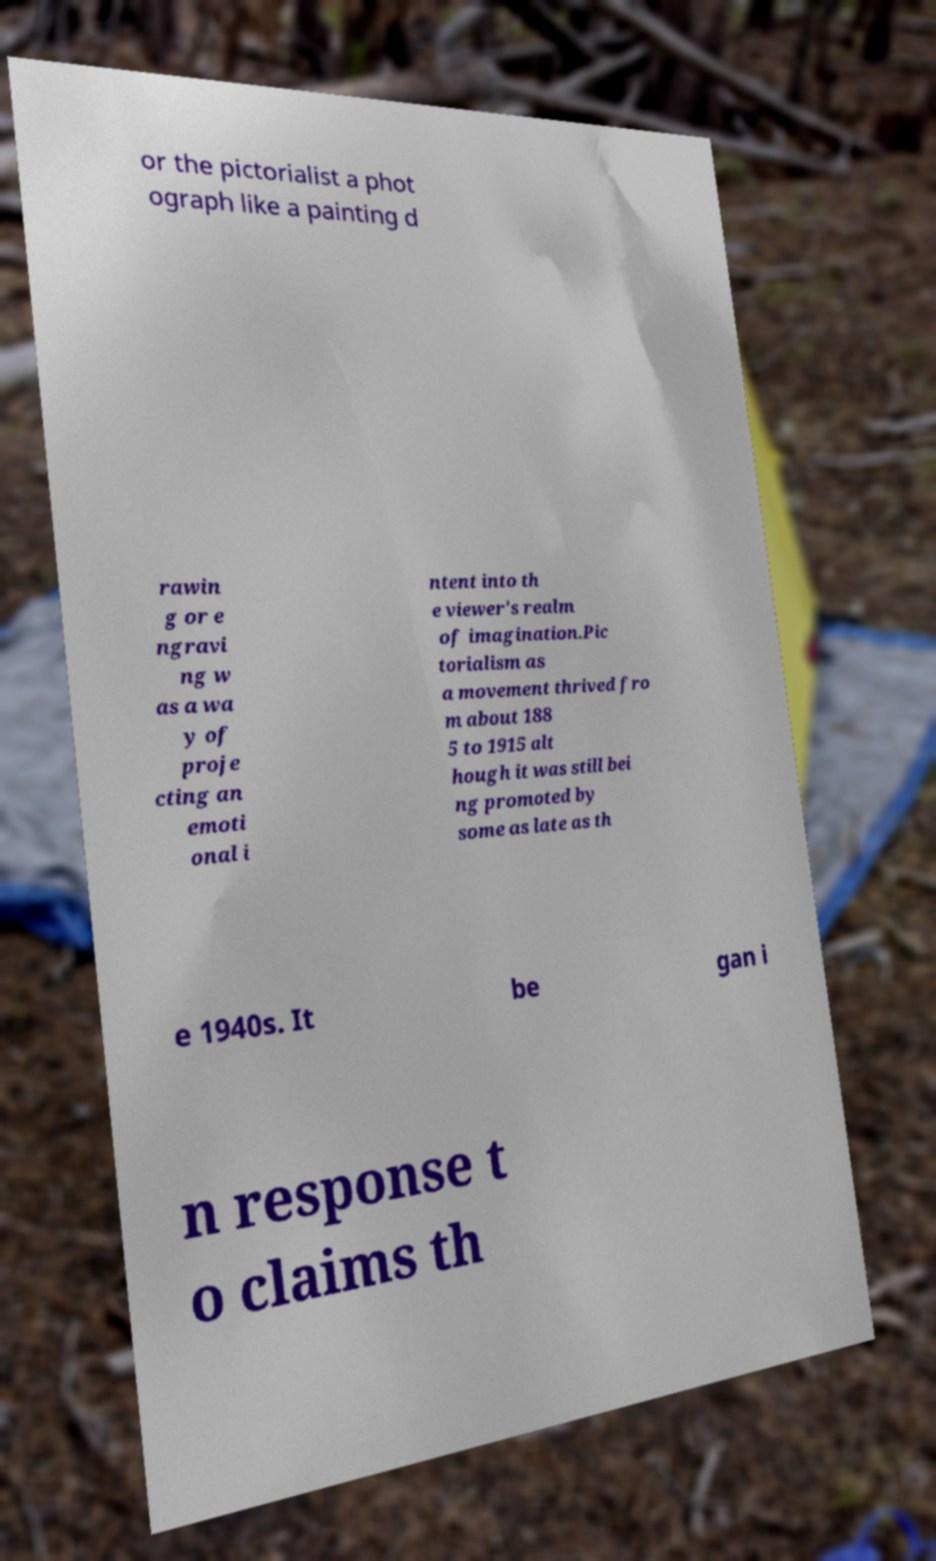Please read and relay the text visible in this image. What does it say? or the pictorialist a phot ograph like a painting d rawin g or e ngravi ng w as a wa y of proje cting an emoti onal i ntent into th e viewer's realm of imagination.Pic torialism as a movement thrived fro m about 188 5 to 1915 alt hough it was still bei ng promoted by some as late as th e 1940s. It be gan i n response t o claims th 